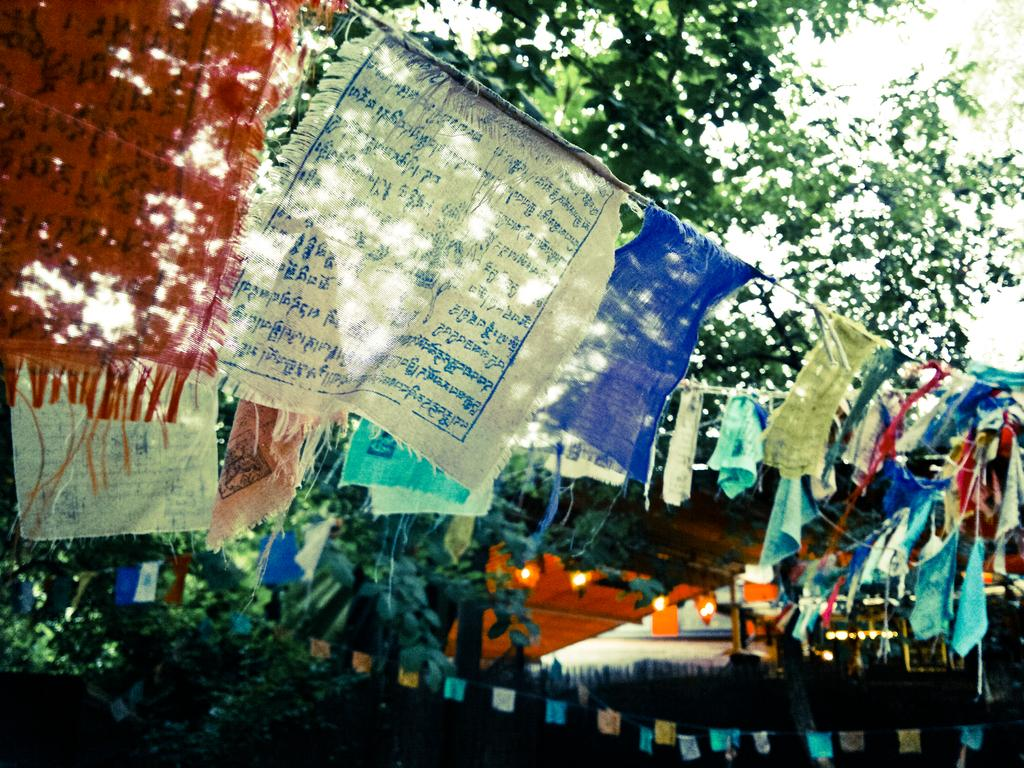What is hanging from the rope in the image? There are flags on a rope in the image. What is written or depicted on the flags? There is text on the flags. What can be seen in the background of the image? There are leaves of a tree in the background of the image. What is located at the bottom of the image? There are lights at the bottom of the image. What type of bread can be seen in the image? There is no bread present in the image. How many tomatoes are hanging from the tree in the image? There are no tomatoes or trees present in the image; it only features flags on a rope, text, and lights. 